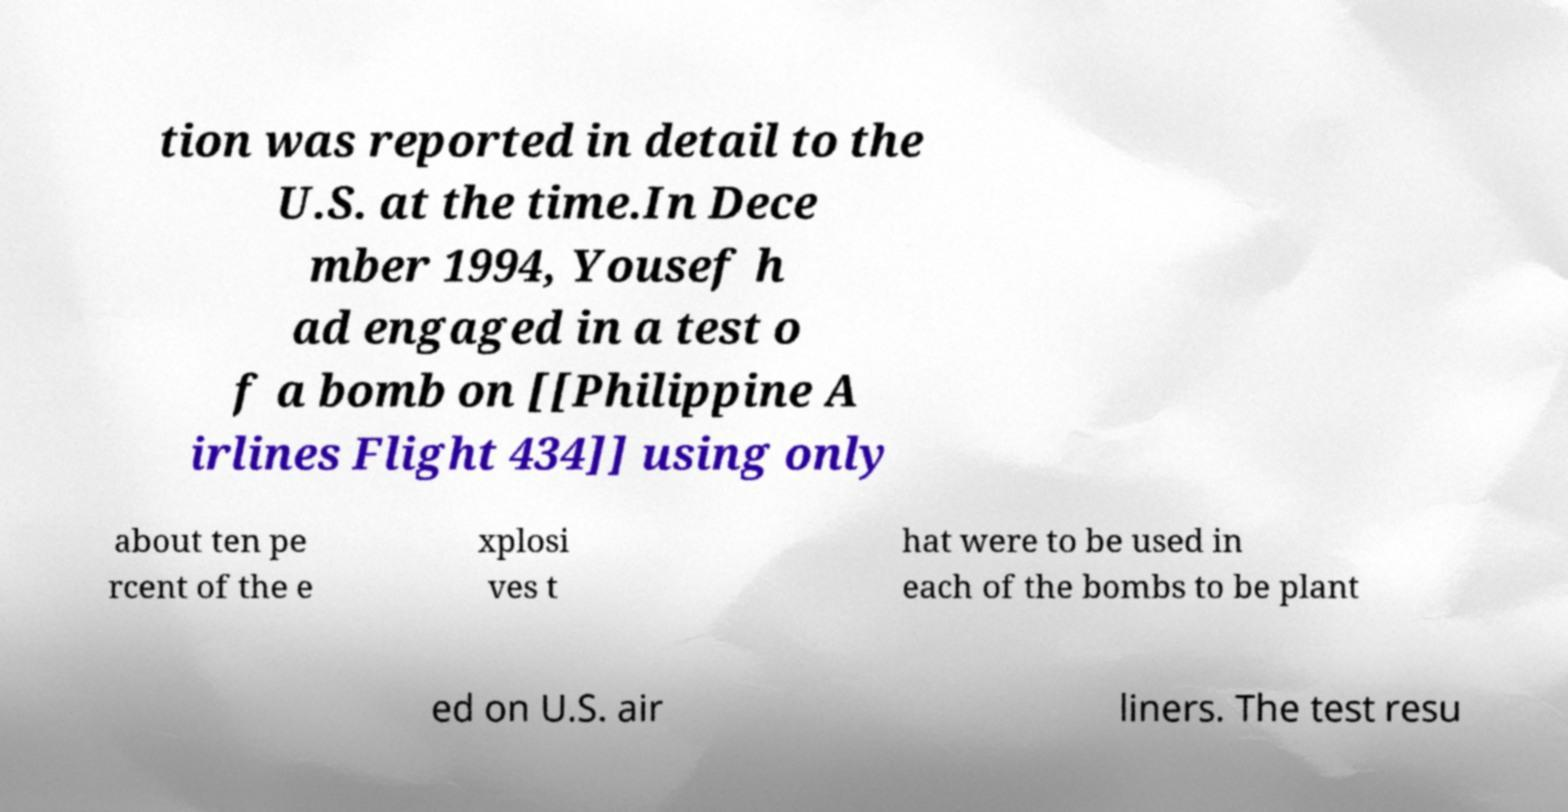Could you assist in decoding the text presented in this image and type it out clearly? tion was reported in detail to the U.S. at the time.In Dece mber 1994, Yousef h ad engaged in a test o f a bomb on [[Philippine A irlines Flight 434]] using only about ten pe rcent of the e xplosi ves t hat were to be used in each of the bombs to be plant ed on U.S. air liners. The test resu 